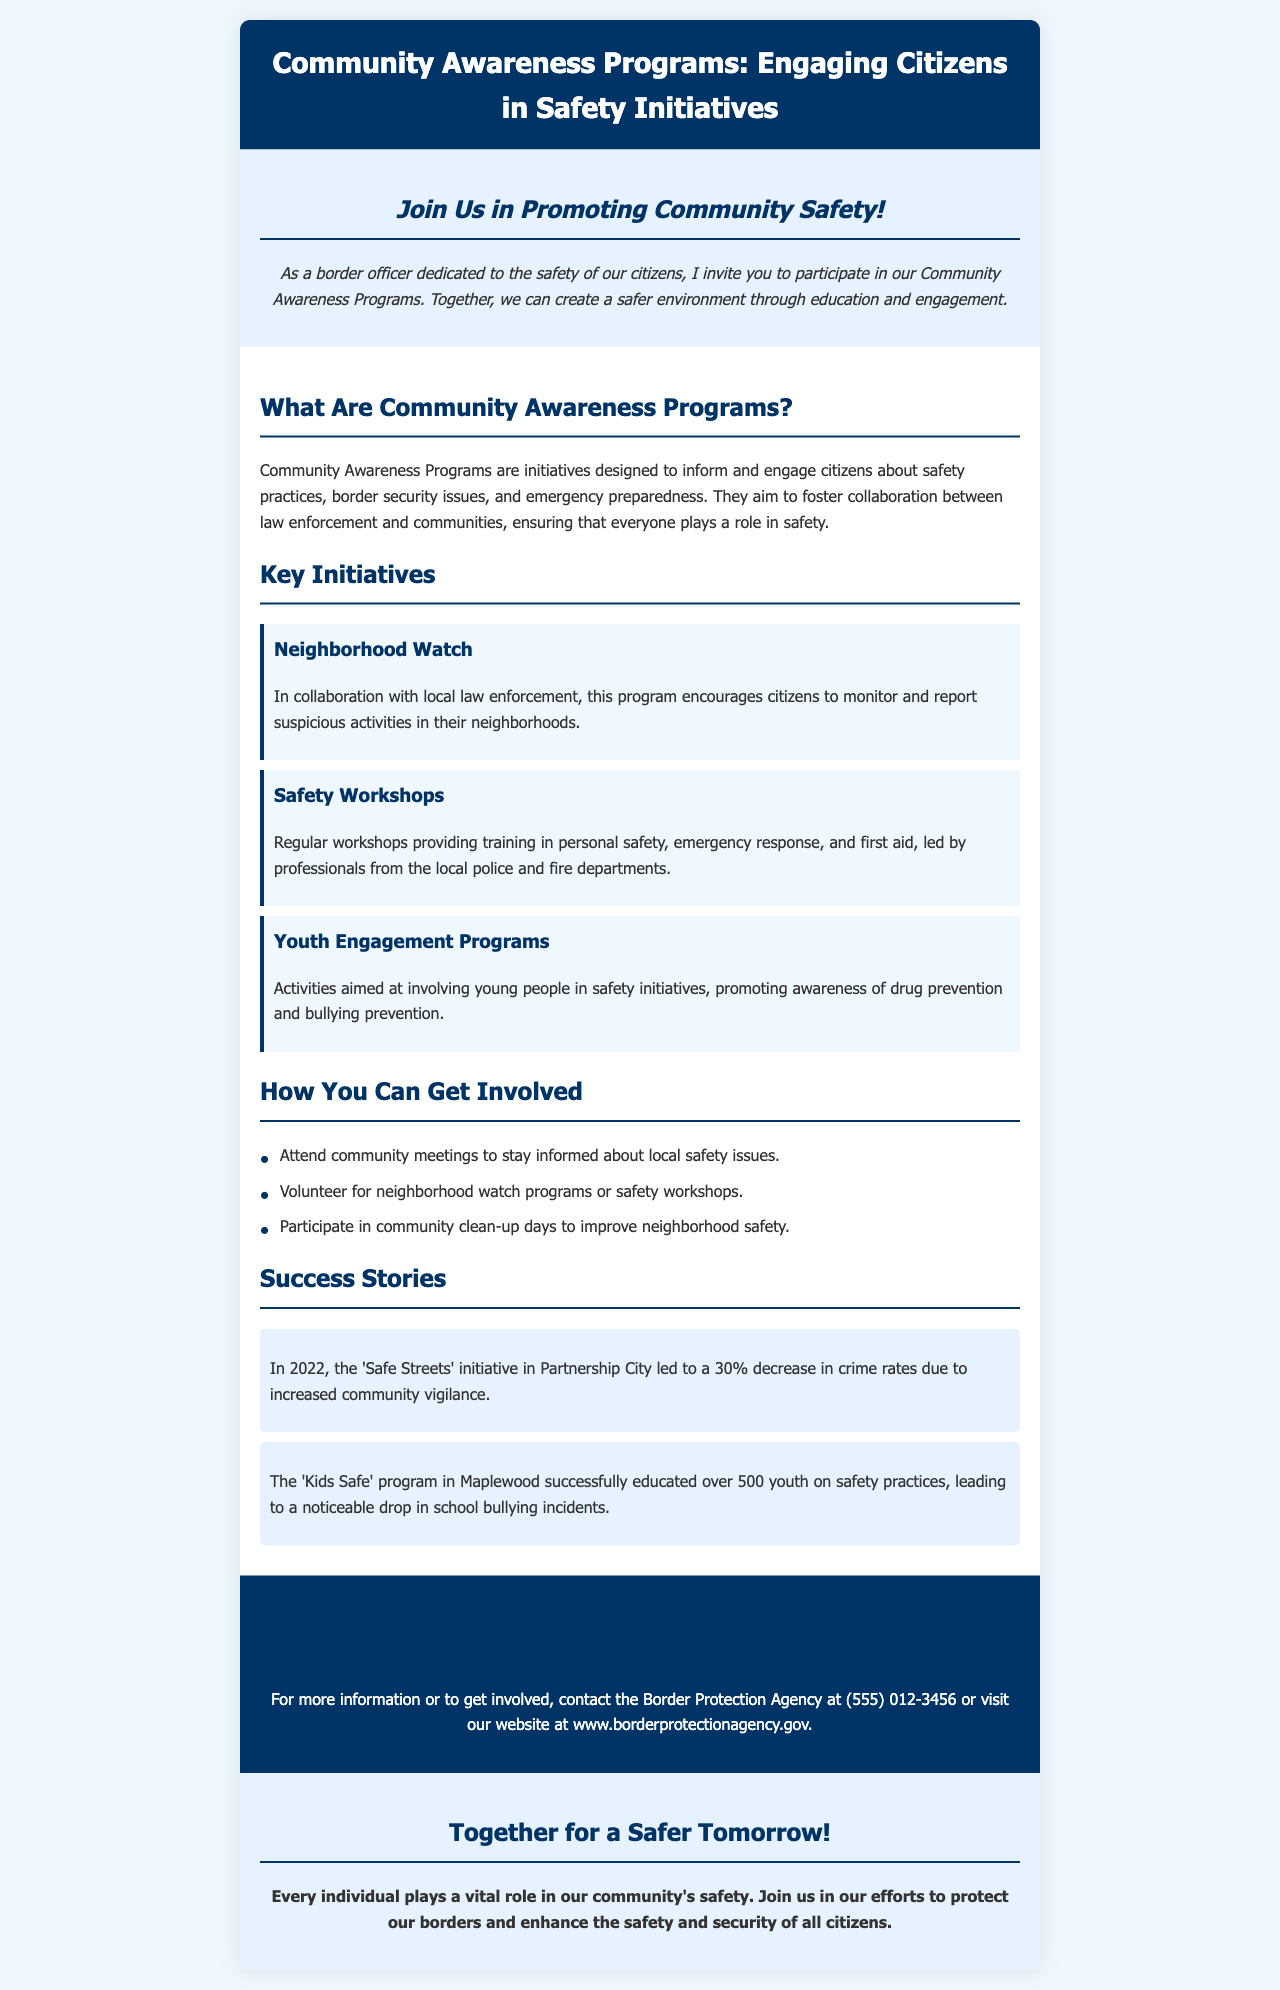What are Community Awareness Programs? Community Awareness Programs are initiatives designed to inform and engage citizens about safety practices, border security issues, and emergency preparedness.
Answer: Initiatives designed to inform and engage citizens What is the contact number for the Border Protection Agency? The contact number for the Border Protection Agency is listed in the contact section of the brochure.
Answer: (555) 012-3456 Which program led to a decrease in crime rates? The success story highlights a program that led to a decrease in crime rates due to community vigilance.
Answer: 'Safe Streets' initiative What type of training do Safety Workshops provide? The brochure specifies the type of training provided in Safety Workshops in the content section.
Answer: Personal safety, emergency response, and first aid How can citizens improve neighborhood safety according to the brochure? The document outlines specific actions citizens can take to improve neighborhood safety.
Answer: Participate in community clean-up days 